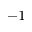<formula> <loc_0><loc_0><loc_500><loc_500>^ { - 1 }</formula> 